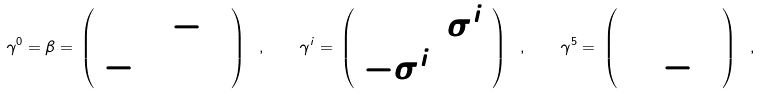Convert formula to latex. <formula><loc_0><loc_0><loc_500><loc_500>\gamma ^ { 0 } = \beta = \, \left ( \begin{array} { c c } 0 & - 1 \\ - 1 & 0 \end{array} \right ) \ , \quad \gamma ^ { i } = \, \left ( \begin{array} { c c } 0 & \sigma ^ { i } \\ - \sigma ^ { i } & 0 \end{array} \right ) \ , \quad \gamma ^ { 5 } = \, \left ( \begin{array} { c c } 1 & \\ & - 1 \end{array} \right ) \ ,</formula> 